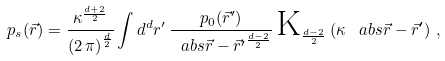Convert formula to latex. <formula><loc_0><loc_0><loc_500><loc_500>p _ { s } ( \vec { r } ) = \frac { \kappa ^ { \frac { d + 2 } { 2 } } } { \left ( 2 \, \pi \right ) ^ { \frac { d } { 2 } } } \int d ^ { d } r ^ { \prime } \, \frac { p _ { 0 } ( \vec { r } ^ { \prime } ) } { \ a b s { \vec { r } - \vec { r } ^ { \prime } } ^ { \frac { d - 2 } { 2 } } } \, \text {K} _ { \frac { d - 2 } { 2 } } \left ( \kappa \, \ a b s { \vec { r } - \vec { r } ^ { \prime } } \right ) \, ,</formula> 